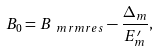<formula> <loc_0><loc_0><loc_500><loc_500>B _ { 0 } = B _ { \ m r m { r e s } } - \frac { \Delta _ { m } } { E _ { m } ^ { \prime } } ,</formula> 